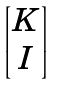Convert formula to latex. <formula><loc_0><loc_0><loc_500><loc_500>\begin{bmatrix} K \\ I \end{bmatrix}</formula> 